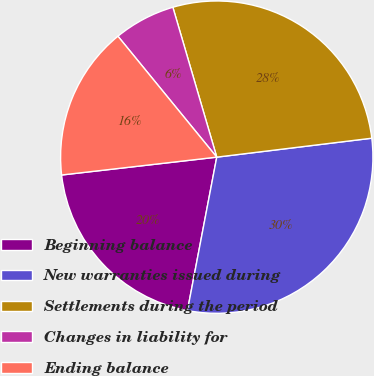Convert chart to OTSL. <chart><loc_0><loc_0><loc_500><loc_500><pie_chart><fcel>Beginning balance<fcel>New warranties issued during<fcel>Settlements during the period<fcel>Changes in liability for<fcel>Ending balance<nl><fcel>20.17%<fcel>29.94%<fcel>27.6%<fcel>6.37%<fcel>15.92%<nl></chart> 